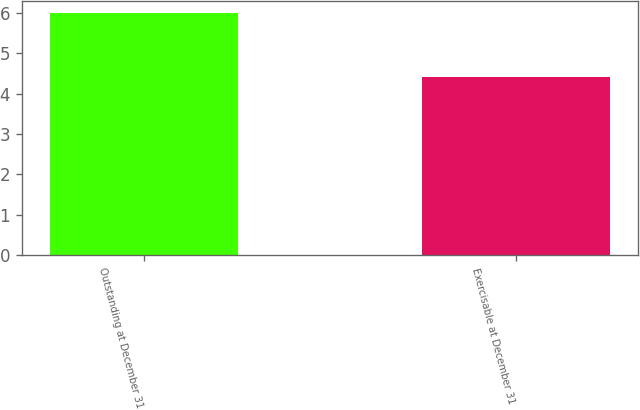Convert chart to OTSL. <chart><loc_0><loc_0><loc_500><loc_500><bar_chart><fcel>Outstanding at December 31<fcel>Exercisable at December 31<nl><fcel>6<fcel>4.4<nl></chart> 